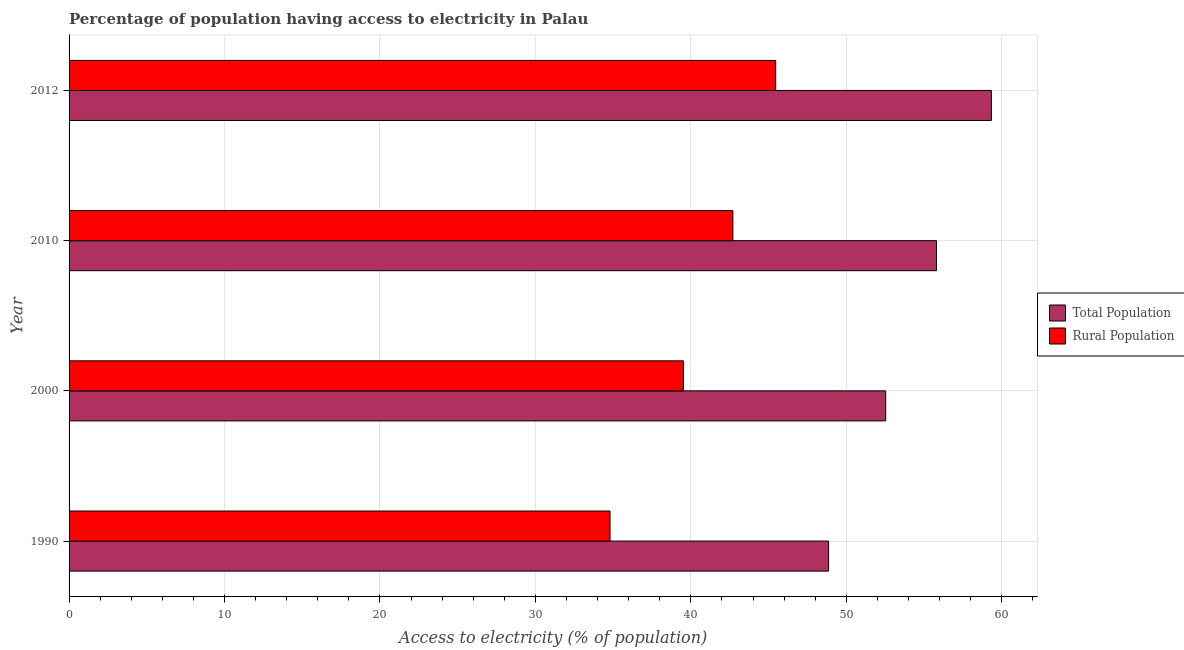How many different coloured bars are there?
Make the answer very short. 2. How many groups of bars are there?
Ensure brevity in your answer.  4. Are the number of bars on each tick of the Y-axis equal?
Your response must be concise. Yes. What is the percentage of population having access to electricity in 2010?
Keep it short and to the point. 55.8. Across all years, what is the maximum percentage of rural population having access to electricity?
Provide a short and direct response. 45.45. Across all years, what is the minimum percentage of rural population having access to electricity?
Give a very brief answer. 34.8. In which year was the percentage of rural population having access to electricity minimum?
Your answer should be compact. 1990. What is the total percentage of population having access to electricity in the graph?
Offer a very short reply. 216.52. What is the difference between the percentage of rural population having access to electricity in 1990 and that in 2000?
Your answer should be compact. -4.72. What is the difference between the percentage of rural population having access to electricity in 2010 and the percentage of population having access to electricity in 1990?
Your answer should be compact. -6.16. What is the average percentage of rural population having access to electricity per year?
Keep it short and to the point. 40.62. In the year 1990, what is the difference between the percentage of rural population having access to electricity and percentage of population having access to electricity?
Give a very brief answer. -14.06. In how many years, is the percentage of rural population having access to electricity greater than 14 %?
Keep it short and to the point. 4. What is the ratio of the percentage of population having access to electricity in 1990 to that in 2010?
Keep it short and to the point. 0.88. What is the difference between the highest and the second highest percentage of rural population having access to electricity?
Your response must be concise. 2.75. What is the difference between the highest and the lowest percentage of rural population having access to electricity?
Ensure brevity in your answer.  10.66. In how many years, is the percentage of population having access to electricity greater than the average percentage of population having access to electricity taken over all years?
Offer a very short reply. 2. Is the sum of the percentage of population having access to electricity in 2010 and 2012 greater than the maximum percentage of rural population having access to electricity across all years?
Give a very brief answer. Yes. What does the 1st bar from the top in 2012 represents?
Offer a very short reply. Rural Population. What does the 2nd bar from the bottom in 2000 represents?
Offer a very short reply. Rural Population. How many bars are there?
Your answer should be compact. 8. Are all the bars in the graph horizontal?
Your answer should be compact. Yes. What is the difference between two consecutive major ticks on the X-axis?
Keep it short and to the point. 10. How many legend labels are there?
Make the answer very short. 2. How are the legend labels stacked?
Your answer should be very brief. Vertical. What is the title of the graph?
Provide a succinct answer. Percentage of population having access to electricity in Palau. What is the label or title of the X-axis?
Give a very brief answer. Access to electricity (% of population). What is the label or title of the Y-axis?
Provide a short and direct response. Year. What is the Access to electricity (% of population) of Total Population in 1990?
Give a very brief answer. 48.86. What is the Access to electricity (% of population) in Rural Population in 1990?
Offer a very short reply. 34.8. What is the Access to electricity (% of population) in Total Population in 2000?
Provide a short and direct response. 52.53. What is the Access to electricity (% of population) in Rural Population in 2000?
Provide a succinct answer. 39.52. What is the Access to electricity (% of population) in Total Population in 2010?
Offer a terse response. 55.8. What is the Access to electricity (% of population) in Rural Population in 2010?
Keep it short and to the point. 42.7. What is the Access to electricity (% of population) of Total Population in 2012?
Your answer should be compact. 59.33. What is the Access to electricity (% of population) in Rural Population in 2012?
Keep it short and to the point. 45.45. Across all years, what is the maximum Access to electricity (% of population) of Total Population?
Keep it short and to the point. 59.33. Across all years, what is the maximum Access to electricity (% of population) of Rural Population?
Keep it short and to the point. 45.45. Across all years, what is the minimum Access to electricity (% of population) in Total Population?
Give a very brief answer. 48.86. Across all years, what is the minimum Access to electricity (% of population) of Rural Population?
Your response must be concise. 34.8. What is the total Access to electricity (% of population) in Total Population in the graph?
Your answer should be compact. 216.52. What is the total Access to electricity (% of population) in Rural Population in the graph?
Provide a succinct answer. 162.47. What is the difference between the Access to electricity (% of population) in Total Population in 1990 and that in 2000?
Your answer should be compact. -3.67. What is the difference between the Access to electricity (% of population) in Rural Population in 1990 and that in 2000?
Ensure brevity in your answer.  -4.72. What is the difference between the Access to electricity (% of population) of Total Population in 1990 and that in 2010?
Provide a short and direct response. -6.94. What is the difference between the Access to electricity (% of population) of Rural Population in 1990 and that in 2010?
Make the answer very short. -7.9. What is the difference between the Access to electricity (% of population) of Total Population in 1990 and that in 2012?
Offer a very short reply. -10.47. What is the difference between the Access to electricity (% of population) in Rural Population in 1990 and that in 2012?
Provide a succinct answer. -10.66. What is the difference between the Access to electricity (% of population) of Total Population in 2000 and that in 2010?
Keep it short and to the point. -3.27. What is the difference between the Access to electricity (% of population) of Rural Population in 2000 and that in 2010?
Provide a succinct answer. -3.18. What is the difference between the Access to electricity (% of population) of Total Population in 2000 and that in 2012?
Your response must be concise. -6.8. What is the difference between the Access to electricity (% of population) in Rural Population in 2000 and that in 2012?
Offer a very short reply. -5.93. What is the difference between the Access to electricity (% of population) in Total Population in 2010 and that in 2012?
Your answer should be compact. -3.53. What is the difference between the Access to electricity (% of population) in Rural Population in 2010 and that in 2012?
Your answer should be compact. -2.75. What is the difference between the Access to electricity (% of population) of Total Population in 1990 and the Access to electricity (% of population) of Rural Population in 2000?
Give a very brief answer. 9.34. What is the difference between the Access to electricity (% of population) in Total Population in 1990 and the Access to electricity (% of population) in Rural Population in 2010?
Provide a succinct answer. 6.16. What is the difference between the Access to electricity (% of population) of Total Population in 1990 and the Access to electricity (% of population) of Rural Population in 2012?
Offer a very short reply. 3.4. What is the difference between the Access to electricity (% of population) in Total Population in 2000 and the Access to electricity (% of population) in Rural Population in 2010?
Your answer should be compact. 9.83. What is the difference between the Access to electricity (% of population) in Total Population in 2000 and the Access to electricity (% of population) in Rural Population in 2012?
Make the answer very short. 7.08. What is the difference between the Access to electricity (% of population) in Total Population in 2010 and the Access to electricity (% of population) in Rural Population in 2012?
Your answer should be very brief. 10.35. What is the average Access to electricity (% of population) in Total Population per year?
Make the answer very short. 54.13. What is the average Access to electricity (% of population) of Rural Population per year?
Provide a short and direct response. 40.62. In the year 1990, what is the difference between the Access to electricity (% of population) of Total Population and Access to electricity (% of population) of Rural Population?
Provide a short and direct response. 14.06. In the year 2000, what is the difference between the Access to electricity (% of population) in Total Population and Access to electricity (% of population) in Rural Population?
Your answer should be compact. 13.01. In the year 2010, what is the difference between the Access to electricity (% of population) in Total Population and Access to electricity (% of population) in Rural Population?
Offer a terse response. 13.1. In the year 2012, what is the difference between the Access to electricity (% of population) of Total Population and Access to electricity (% of population) of Rural Population?
Provide a succinct answer. 13.87. What is the ratio of the Access to electricity (% of population) in Total Population in 1990 to that in 2000?
Keep it short and to the point. 0.93. What is the ratio of the Access to electricity (% of population) in Rural Population in 1990 to that in 2000?
Your response must be concise. 0.88. What is the ratio of the Access to electricity (% of population) of Total Population in 1990 to that in 2010?
Your answer should be very brief. 0.88. What is the ratio of the Access to electricity (% of population) of Rural Population in 1990 to that in 2010?
Your answer should be compact. 0.81. What is the ratio of the Access to electricity (% of population) of Total Population in 1990 to that in 2012?
Your answer should be compact. 0.82. What is the ratio of the Access to electricity (% of population) in Rural Population in 1990 to that in 2012?
Your answer should be very brief. 0.77. What is the ratio of the Access to electricity (% of population) of Total Population in 2000 to that in 2010?
Make the answer very short. 0.94. What is the ratio of the Access to electricity (% of population) of Rural Population in 2000 to that in 2010?
Give a very brief answer. 0.93. What is the ratio of the Access to electricity (% of population) in Total Population in 2000 to that in 2012?
Your answer should be very brief. 0.89. What is the ratio of the Access to electricity (% of population) of Rural Population in 2000 to that in 2012?
Ensure brevity in your answer.  0.87. What is the ratio of the Access to electricity (% of population) in Total Population in 2010 to that in 2012?
Ensure brevity in your answer.  0.94. What is the ratio of the Access to electricity (% of population) of Rural Population in 2010 to that in 2012?
Provide a succinct answer. 0.94. What is the difference between the highest and the second highest Access to electricity (% of population) of Total Population?
Your answer should be compact. 3.53. What is the difference between the highest and the second highest Access to electricity (% of population) of Rural Population?
Ensure brevity in your answer.  2.75. What is the difference between the highest and the lowest Access to electricity (% of population) in Total Population?
Make the answer very short. 10.47. What is the difference between the highest and the lowest Access to electricity (% of population) in Rural Population?
Ensure brevity in your answer.  10.66. 